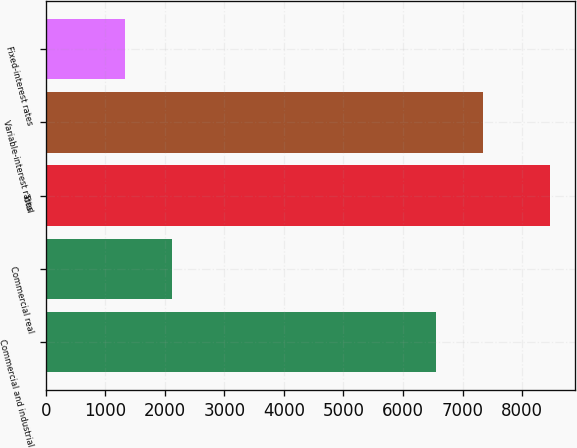Convert chart to OTSL. <chart><loc_0><loc_0><loc_500><loc_500><bar_chart><fcel>Commercial and industrial<fcel>Commercial real<fcel>Total<fcel>Variable-interest rates<fcel>Fixed-interest rates<nl><fcel>6557<fcel>2122.2<fcel>8467<fcel>7350.1<fcel>1329.1<nl></chart> 